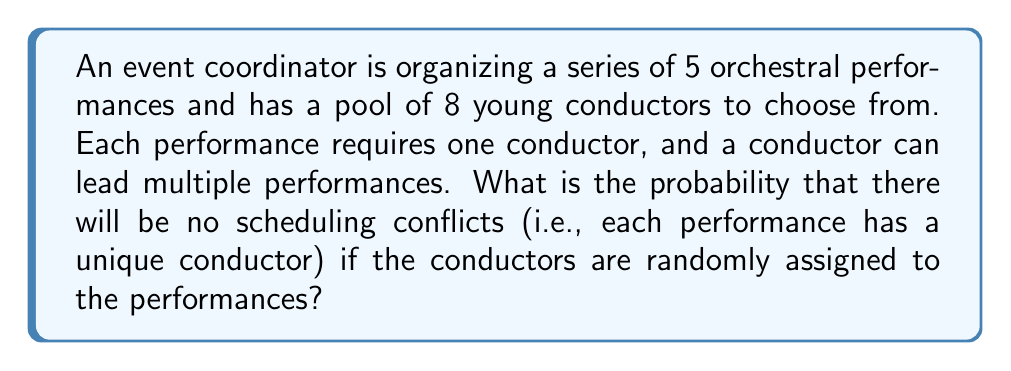Solve this math problem. Let's approach this step-by-step:

1) This problem can be solved using the concept of permutations.

2) We need to calculate the number of ways to assign 5 conductors to 5 performances out of 8 available conductors, where order matters (as each performance is distinct).

3) This is equivalent to calculating the number of permutations of 5 items chosen from 8, denoted as $P(8,5)$.

4) The formula for this permutation is:

   $$P(8,5) = \frac{8!}{(8-5)!} = \frac{8!}{3!}$$

5) Calculating this:
   $$P(8,5) = \frac{8 \cdot 7 \cdot 6 \cdot 5 \cdot 4 \cdot 3!}{3!} = 8 \cdot 7 \cdot 6 \cdot 5 \cdot 4 = 6720$$

6) Now, the total number of ways to assign 8 conductors to 5 performances, allowing repetitions, is $8^5 = 32768$.

7) The probability is therefore:

   $$P(\text{no conflicts}) = \frac{P(8,5)}{8^5} = \frac{6720}{32768} = \frac{105}{512} \approx 0.2051$$
Answer: $\frac{105}{512}$ 